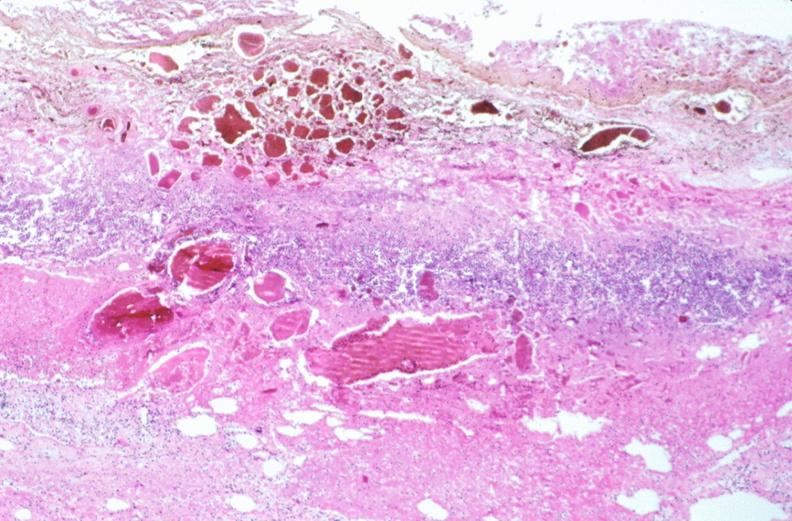what ingested as suicide attempt?
Answer the question using a single word or phrase. Stomach, necrotizing esophagitis and gastritis, sulfuric acid 